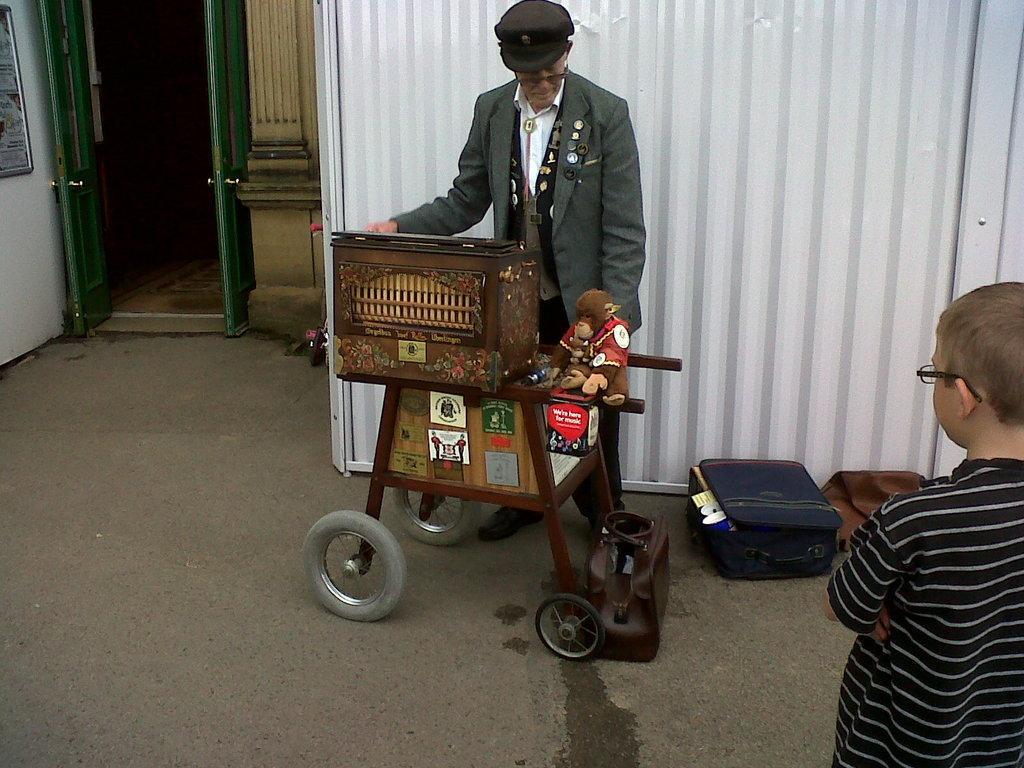Could you give a brief overview of what you see in this image? In this picture I can observe a vehicle in the middle of the picture. It is looking like a trolley. Beside this trolley I can observe a person standing, wearing a coat and cap on his head. On the right side I can observe a boy standing on the floor. On the left side I can observe green color doors. 